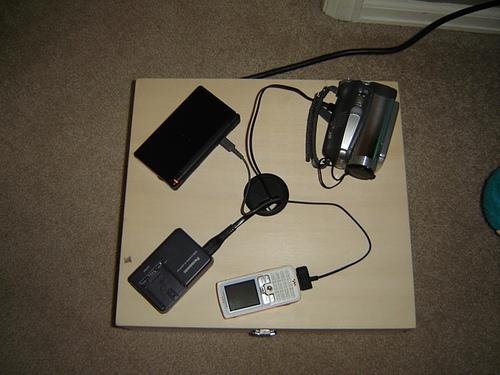Is there a ball on the table?
Write a very short answer. No. What is the name of this console?
Keep it brief. Charging station. What kind of instrument is this?
Be succinct. Camcorder. How many devices are being charged?
Give a very brief answer. 4. What color is the background?
Write a very short answer. Brown. What is this equipment?
Answer briefly. Electronics. What are the chords for?
Concise answer only. Charging. What are the devices lying on?
Quick response, please. Wood. When did this gaming system first hit the market?
Answer briefly. 1990. Which device could be a camera?
Answer briefly. Top right. What activity are these things used for?
Quick response, please. Recording. What type of material is this object resting on?
Quick response, please. Wood. Is this likely a man's bag?
Write a very short answer. Yes. What are the black objects on the board?
Quick response, please. Electronics. Is the phone working?
Be succinct. Yes. How many plugs are on the board?
Write a very short answer. 4. What room is this?
Quick response, please. Living room. 